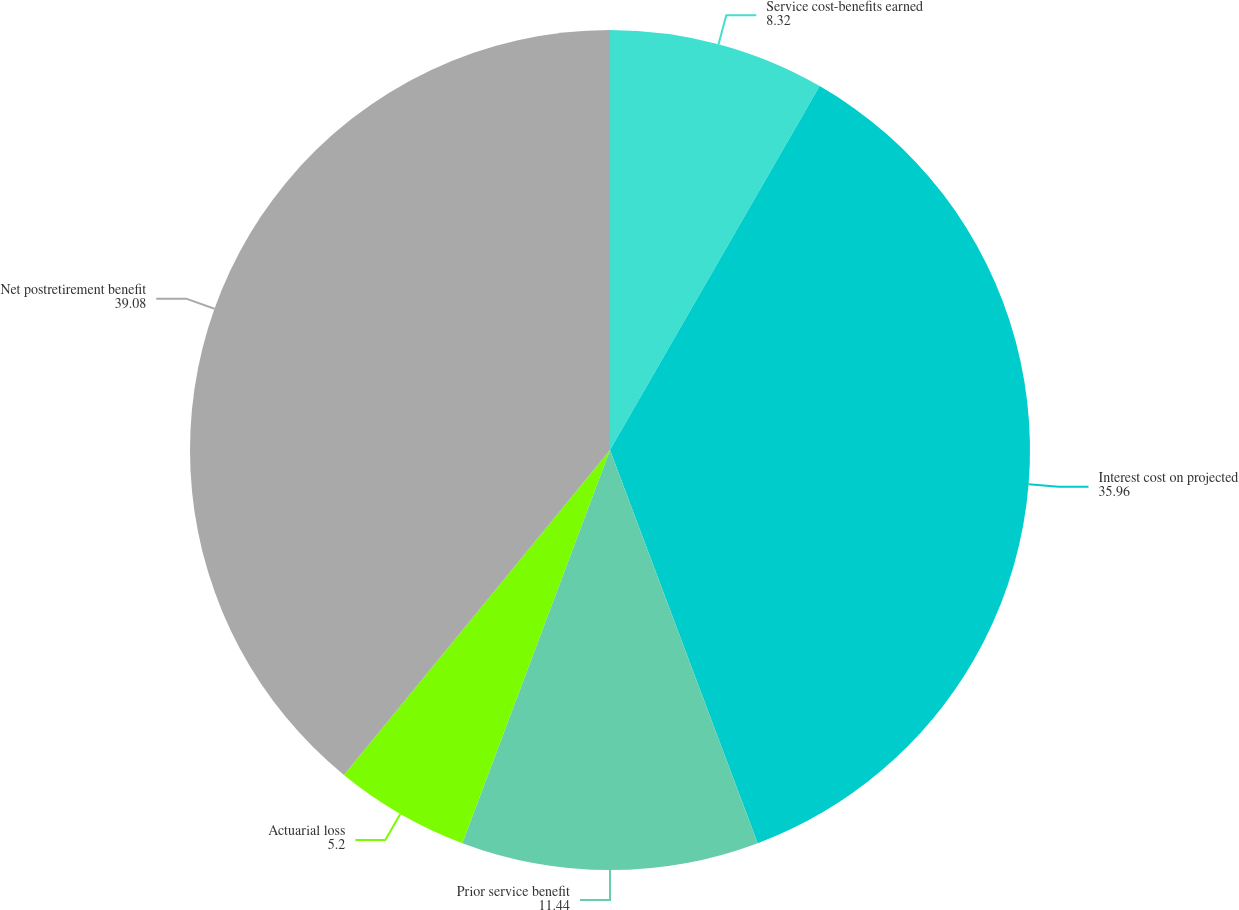Convert chart to OTSL. <chart><loc_0><loc_0><loc_500><loc_500><pie_chart><fcel>Service cost-benefits earned<fcel>Interest cost on projected<fcel>Prior service benefit<fcel>Actuarial loss<fcel>Net postretirement benefit<nl><fcel>8.32%<fcel>35.96%<fcel>11.44%<fcel>5.2%<fcel>39.08%<nl></chart> 